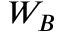<formula> <loc_0><loc_0><loc_500><loc_500>W _ { B }</formula> 